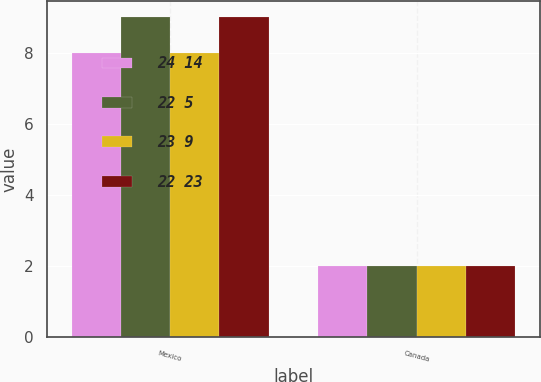Convert chart to OTSL. <chart><loc_0><loc_0><loc_500><loc_500><stacked_bar_chart><ecel><fcel>Mexico<fcel>Canada<nl><fcel>24 14<fcel>8<fcel>2<nl><fcel>22 5<fcel>9<fcel>2<nl><fcel>23 9<fcel>8<fcel>2<nl><fcel>22 23<fcel>9<fcel>2<nl></chart> 